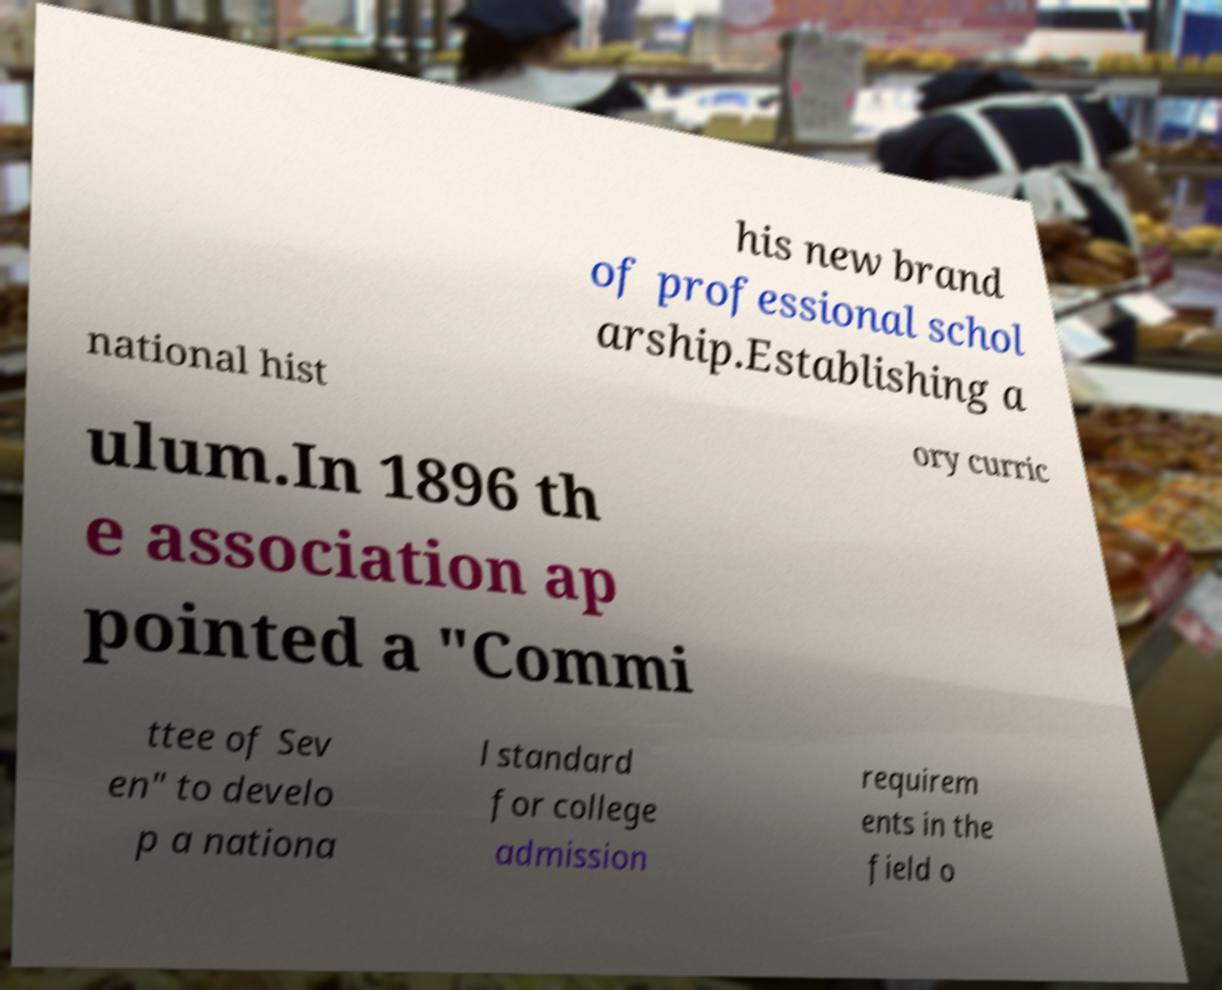Please identify and transcribe the text found in this image. his new brand of professional schol arship.Establishing a national hist ory curric ulum.In 1896 th e association ap pointed a "Commi ttee of Sev en" to develo p a nationa l standard for college admission requirem ents in the field o 